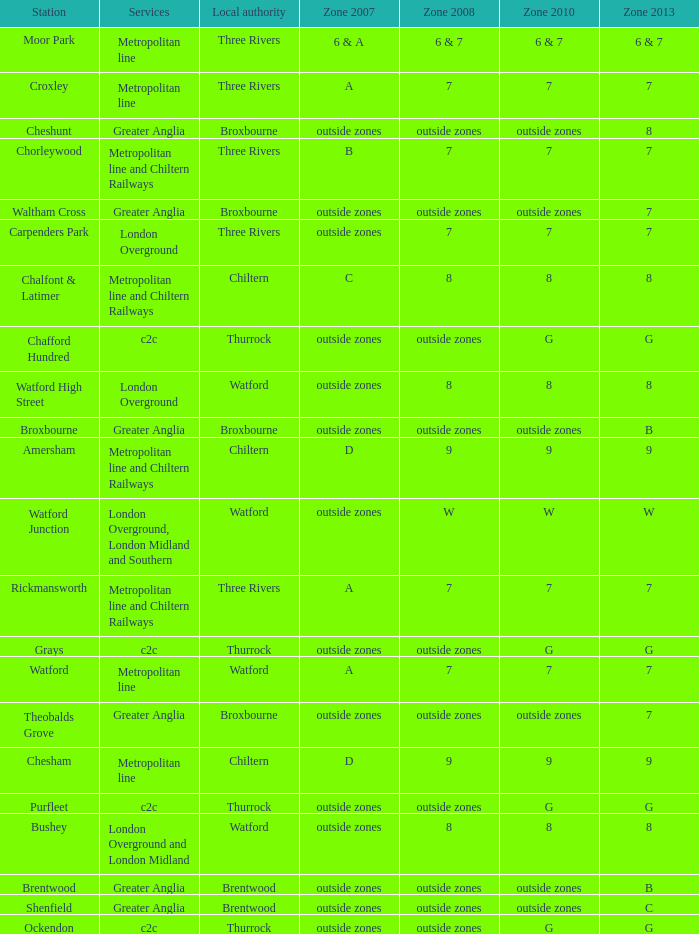Which Station has a Zone 2008 of 8, and a Zone 2007 of outside zones, and Services of london overground? Watford High Street. 